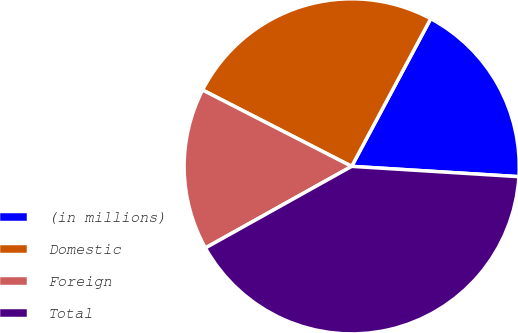Convert chart to OTSL. <chart><loc_0><loc_0><loc_500><loc_500><pie_chart><fcel>(in millions)<fcel>Domestic<fcel>Foreign<fcel>Total<nl><fcel>18.16%<fcel>25.29%<fcel>15.63%<fcel>40.92%<nl></chart> 